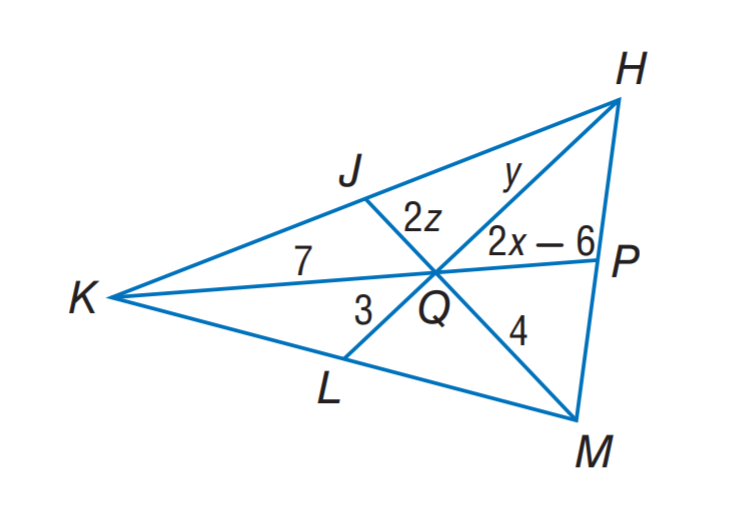Answer the mathemtical geometry problem and directly provide the correct option letter.
Question: If J, P, and L are the midpoints of K H, H M and M K, respectively. Find z.
Choices: A: 1 B: 2 C: 3 D: 4 A 